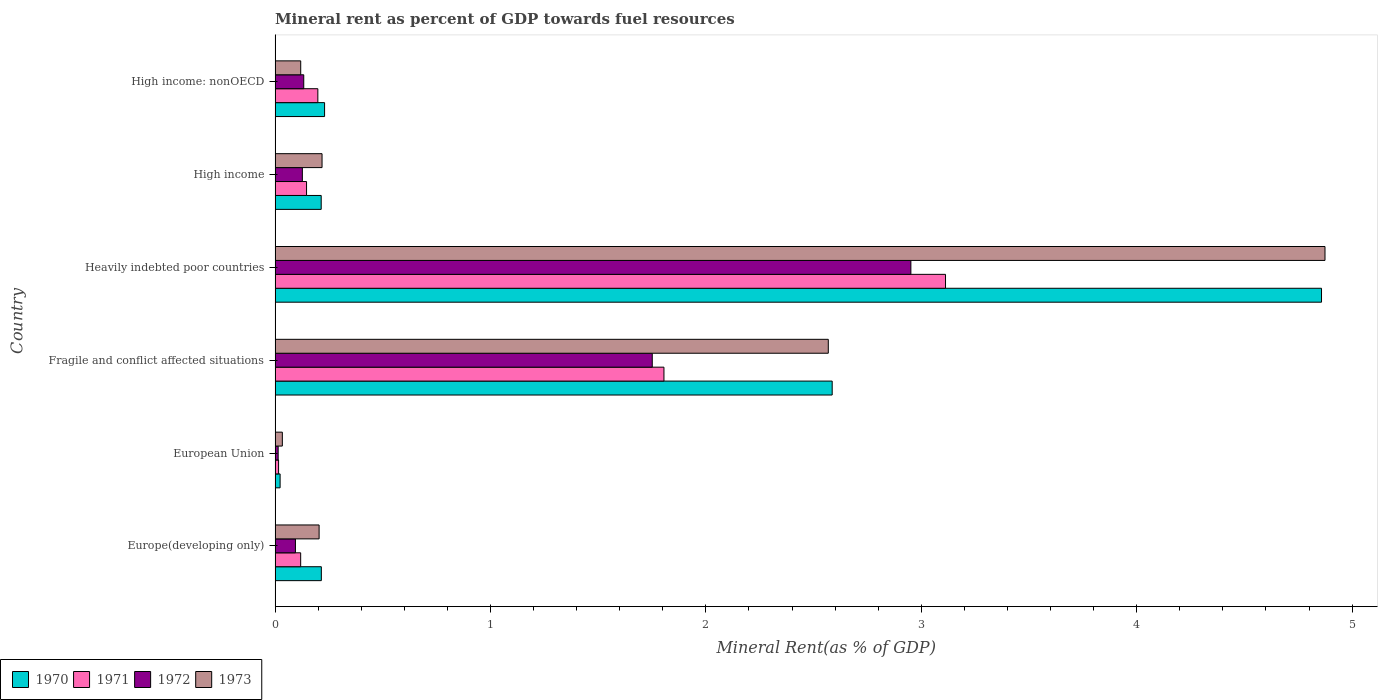How many groups of bars are there?
Make the answer very short. 6. Are the number of bars per tick equal to the number of legend labels?
Provide a succinct answer. Yes. Are the number of bars on each tick of the Y-axis equal?
Your answer should be compact. Yes. How many bars are there on the 1st tick from the bottom?
Offer a terse response. 4. What is the label of the 2nd group of bars from the top?
Your response must be concise. High income. In how many cases, is the number of bars for a given country not equal to the number of legend labels?
Your response must be concise. 0. What is the mineral rent in 1970 in Fragile and conflict affected situations?
Your response must be concise. 2.59. Across all countries, what is the maximum mineral rent in 1973?
Offer a terse response. 4.87. Across all countries, what is the minimum mineral rent in 1970?
Your answer should be compact. 0.02. In which country was the mineral rent in 1973 maximum?
Offer a very short reply. Heavily indebted poor countries. What is the total mineral rent in 1973 in the graph?
Ensure brevity in your answer.  8.02. What is the difference between the mineral rent in 1970 in Heavily indebted poor countries and that in High income: nonOECD?
Your response must be concise. 4.63. What is the difference between the mineral rent in 1972 in Heavily indebted poor countries and the mineral rent in 1971 in Fragile and conflict affected situations?
Provide a short and direct response. 1.15. What is the average mineral rent in 1973 per country?
Ensure brevity in your answer.  1.34. What is the difference between the mineral rent in 1971 and mineral rent in 1972 in Fragile and conflict affected situations?
Your response must be concise. 0.05. In how many countries, is the mineral rent in 1972 greater than 0.8 %?
Provide a succinct answer. 2. What is the ratio of the mineral rent in 1971 in High income to that in High income: nonOECD?
Make the answer very short. 0.74. Is the mineral rent in 1972 in Fragile and conflict affected situations less than that in Heavily indebted poor countries?
Ensure brevity in your answer.  Yes. Is the difference between the mineral rent in 1971 in European Union and High income greater than the difference between the mineral rent in 1972 in European Union and High income?
Keep it short and to the point. No. What is the difference between the highest and the second highest mineral rent in 1972?
Give a very brief answer. 1.2. What is the difference between the highest and the lowest mineral rent in 1972?
Your answer should be compact. 2.94. What does the 1st bar from the top in High income: nonOECD represents?
Offer a very short reply. 1973. What does the 3rd bar from the bottom in High income represents?
Make the answer very short. 1972. How many bars are there?
Provide a succinct answer. 24. Are all the bars in the graph horizontal?
Keep it short and to the point. Yes. Are the values on the major ticks of X-axis written in scientific E-notation?
Ensure brevity in your answer.  No. Does the graph contain any zero values?
Your answer should be very brief. No. What is the title of the graph?
Keep it short and to the point. Mineral rent as percent of GDP towards fuel resources. Does "1978" appear as one of the legend labels in the graph?
Provide a short and direct response. No. What is the label or title of the X-axis?
Provide a succinct answer. Mineral Rent(as % of GDP). What is the label or title of the Y-axis?
Offer a terse response. Country. What is the Mineral Rent(as % of GDP) in 1970 in Europe(developing only)?
Provide a short and direct response. 0.21. What is the Mineral Rent(as % of GDP) in 1971 in Europe(developing only)?
Provide a short and direct response. 0.12. What is the Mineral Rent(as % of GDP) of 1972 in Europe(developing only)?
Give a very brief answer. 0.09. What is the Mineral Rent(as % of GDP) in 1973 in Europe(developing only)?
Keep it short and to the point. 0.2. What is the Mineral Rent(as % of GDP) of 1970 in European Union?
Give a very brief answer. 0.02. What is the Mineral Rent(as % of GDP) of 1971 in European Union?
Your response must be concise. 0.02. What is the Mineral Rent(as % of GDP) of 1972 in European Union?
Give a very brief answer. 0.01. What is the Mineral Rent(as % of GDP) of 1973 in European Union?
Provide a succinct answer. 0.03. What is the Mineral Rent(as % of GDP) of 1970 in Fragile and conflict affected situations?
Your answer should be very brief. 2.59. What is the Mineral Rent(as % of GDP) in 1971 in Fragile and conflict affected situations?
Keep it short and to the point. 1.81. What is the Mineral Rent(as % of GDP) in 1972 in Fragile and conflict affected situations?
Make the answer very short. 1.75. What is the Mineral Rent(as % of GDP) in 1973 in Fragile and conflict affected situations?
Your response must be concise. 2.57. What is the Mineral Rent(as % of GDP) in 1970 in Heavily indebted poor countries?
Offer a terse response. 4.86. What is the Mineral Rent(as % of GDP) of 1971 in Heavily indebted poor countries?
Keep it short and to the point. 3.11. What is the Mineral Rent(as % of GDP) in 1972 in Heavily indebted poor countries?
Give a very brief answer. 2.95. What is the Mineral Rent(as % of GDP) of 1973 in Heavily indebted poor countries?
Give a very brief answer. 4.87. What is the Mineral Rent(as % of GDP) in 1970 in High income?
Provide a succinct answer. 0.21. What is the Mineral Rent(as % of GDP) of 1971 in High income?
Give a very brief answer. 0.15. What is the Mineral Rent(as % of GDP) in 1972 in High income?
Offer a terse response. 0.13. What is the Mineral Rent(as % of GDP) of 1973 in High income?
Offer a terse response. 0.22. What is the Mineral Rent(as % of GDP) in 1970 in High income: nonOECD?
Provide a succinct answer. 0.23. What is the Mineral Rent(as % of GDP) of 1971 in High income: nonOECD?
Make the answer very short. 0.2. What is the Mineral Rent(as % of GDP) in 1972 in High income: nonOECD?
Keep it short and to the point. 0.13. What is the Mineral Rent(as % of GDP) in 1973 in High income: nonOECD?
Make the answer very short. 0.12. Across all countries, what is the maximum Mineral Rent(as % of GDP) of 1970?
Give a very brief answer. 4.86. Across all countries, what is the maximum Mineral Rent(as % of GDP) of 1971?
Keep it short and to the point. 3.11. Across all countries, what is the maximum Mineral Rent(as % of GDP) in 1972?
Give a very brief answer. 2.95. Across all countries, what is the maximum Mineral Rent(as % of GDP) in 1973?
Offer a very short reply. 4.87. Across all countries, what is the minimum Mineral Rent(as % of GDP) of 1970?
Ensure brevity in your answer.  0.02. Across all countries, what is the minimum Mineral Rent(as % of GDP) in 1971?
Provide a short and direct response. 0.02. Across all countries, what is the minimum Mineral Rent(as % of GDP) in 1972?
Provide a succinct answer. 0.01. Across all countries, what is the minimum Mineral Rent(as % of GDP) of 1973?
Your response must be concise. 0.03. What is the total Mineral Rent(as % of GDP) of 1970 in the graph?
Your answer should be compact. 8.13. What is the total Mineral Rent(as % of GDP) of 1971 in the graph?
Offer a very short reply. 5.4. What is the total Mineral Rent(as % of GDP) in 1972 in the graph?
Offer a terse response. 5.07. What is the total Mineral Rent(as % of GDP) of 1973 in the graph?
Offer a terse response. 8.02. What is the difference between the Mineral Rent(as % of GDP) in 1970 in Europe(developing only) and that in European Union?
Your answer should be compact. 0.19. What is the difference between the Mineral Rent(as % of GDP) of 1971 in Europe(developing only) and that in European Union?
Make the answer very short. 0.1. What is the difference between the Mineral Rent(as % of GDP) in 1972 in Europe(developing only) and that in European Union?
Offer a very short reply. 0.08. What is the difference between the Mineral Rent(as % of GDP) of 1973 in Europe(developing only) and that in European Union?
Your answer should be compact. 0.17. What is the difference between the Mineral Rent(as % of GDP) of 1970 in Europe(developing only) and that in Fragile and conflict affected situations?
Provide a short and direct response. -2.37. What is the difference between the Mineral Rent(as % of GDP) in 1971 in Europe(developing only) and that in Fragile and conflict affected situations?
Ensure brevity in your answer.  -1.69. What is the difference between the Mineral Rent(as % of GDP) in 1972 in Europe(developing only) and that in Fragile and conflict affected situations?
Your answer should be compact. -1.66. What is the difference between the Mineral Rent(as % of GDP) in 1973 in Europe(developing only) and that in Fragile and conflict affected situations?
Give a very brief answer. -2.36. What is the difference between the Mineral Rent(as % of GDP) in 1970 in Europe(developing only) and that in Heavily indebted poor countries?
Ensure brevity in your answer.  -4.64. What is the difference between the Mineral Rent(as % of GDP) of 1971 in Europe(developing only) and that in Heavily indebted poor countries?
Your response must be concise. -2.99. What is the difference between the Mineral Rent(as % of GDP) in 1972 in Europe(developing only) and that in Heavily indebted poor countries?
Provide a succinct answer. -2.86. What is the difference between the Mineral Rent(as % of GDP) in 1973 in Europe(developing only) and that in Heavily indebted poor countries?
Offer a very short reply. -4.67. What is the difference between the Mineral Rent(as % of GDP) in 1970 in Europe(developing only) and that in High income?
Your answer should be very brief. 0. What is the difference between the Mineral Rent(as % of GDP) of 1971 in Europe(developing only) and that in High income?
Keep it short and to the point. -0.03. What is the difference between the Mineral Rent(as % of GDP) of 1972 in Europe(developing only) and that in High income?
Provide a succinct answer. -0.03. What is the difference between the Mineral Rent(as % of GDP) in 1973 in Europe(developing only) and that in High income?
Make the answer very short. -0.01. What is the difference between the Mineral Rent(as % of GDP) in 1970 in Europe(developing only) and that in High income: nonOECD?
Give a very brief answer. -0.01. What is the difference between the Mineral Rent(as % of GDP) in 1971 in Europe(developing only) and that in High income: nonOECD?
Give a very brief answer. -0.08. What is the difference between the Mineral Rent(as % of GDP) in 1972 in Europe(developing only) and that in High income: nonOECD?
Give a very brief answer. -0.04. What is the difference between the Mineral Rent(as % of GDP) of 1973 in Europe(developing only) and that in High income: nonOECD?
Provide a succinct answer. 0.09. What is the difference between the Mineral Rent(as % of GDP) in 1970 in European Union and that in Fragile and conflict affected situations?
Provide a succinct answer. -2.56. What is the difference between the Mineral Rent(as % of GDP) of 1971 in European Union and that in Fragile and conflict affected situations?
Offer a very short reply. -1.79. What is the difference between the Mineral Rent(as % of GDP) of 1972 in European Union and that in Fragile and conflict affected situations?
Your response must be concise. -1.74. What is the difference between the Mineral Rent(as % of GDP) of 1973 in European Union and that in Fragile and conflict affected situations?
Your answer should be very brief. -2.53. What is the difference between the Mineral Rent(as % of GDP) in 1970 in European Union and that in Heavily indebted poor countries?
Keep it short and to the point. -4.83. What is the difference between the Mineral Rent(as % of GDP) in 1971 in European Union and that in Heavily indebted poor countries?
Your answer should be compact. -3.1. What is the difference between the Mineral Rent(as % of GDP) of 1972 in European Union and that in Heavily indebted poor countries?
Give a very brief answer. -2.94. What is the difference between the Mineral Rent(as % of GDP) of 1973 in European Union and that in Heavily indebted poor countries?
Your answer should be very brief. -4.84. What is the difference between the Mineral Rent(as % of GDP) of 1970 in European Union and that in High income?
Provide a succinct answer. -0.19. What is the difference between the Mineral Rent(as % of GDP) in 1971 in European Union and that in High income?
Offer a very short reply. -0.13. What is the difference between the Mineral Rent(as % of GDP) in 1972 in European Union and that in High income?
Your response must be concise. -0.11. What is the difference between the Mineral Rent(as % of GDP) of 1973 in European Union and that in High income?
Your answer should be compact. -0.18. What is the difference between the Mineral Rent(as % of GDP) of 1970 in European Union and that in High income: nonOECD?
Your answer should be compact. -0.21. What is the difference between the Mineral Rent(as % of GDP) in 1971 in European Union and that in High income: nonOECD?
Your response must be concise. -0.18. What is the difference between the Mineral Rent(as % of GDP) of 1972 in European Union and that in High income: nonOECD?
Your answer should be compact. -0.12. What is the difference between the Mineral Rent(as % of GDP) of 1973 in European Union and that in High income: nonOECD?
Your answer should be very brief. -0.09. What is the difference between the Mineral Rent(as % of GDP) in 1970 in Fragile and conflict affected situations and that in Heavily indebted poor countries?
Give a very brief answer. -2.27. What is the difference between the Mineral Rent(as % of GDP) of 1971 in Fragile and conflict affected situations and that in Heavily indebted poor countries?
Your response must be concise. -1.31. What is the difference between the Mineral Rent(as % of GDP) in 1972 in Fragile and conflict affected situations and that in Heavily indebted poor countries?
Give a very brief answer. -1.2. What is the difference between the Mineral Rent(as % of GDP) in 1973 in Fragile and conflict affected situations and that in Heavily indebted poor countries?
Offer a very short reply. -2.31. What is the difference between the Mineral Rent(as % of GDP) in 1970 in Fragile and conflict affected situations and that in High income?
Provide a short and direct response. 2.37. What is the difference between the Mineral Rent(as % of GDP) of 1971 in Fragile and conflict affected situations and that in High income?
Your answer should be compact. 1.66. What is the difference between the Mineral Rent(as % of GDP) of 1972 in Fragile and conflict affected situations and that in High income?
Make the answer very short. 1.62. What is the difference between the Mineral Rent(as % of GDP) of 1973 in Fragile and conflict affected situations and that in High income?
Your answer should be very brief. 2.35. What is the difference between the Mineral Rent(as % of GDP) of 1970 in Fragile and conflict affected situations and that in High income: nonOECD?
Keep it short and to the point. 2.36. What is the difference between the Mineral Rent(as % of GDP) of 1971 in Fragile and conflict affected situations and that in High income: nonOECD?
Your answer should be compact. 1.61. What is the difference between the Mineral Rent(as % of GDP) in 1972 in Fragile and conflict affected situations and that in High income: nonOECD?
Ensure brevity in your answer.  1.62. What is the difference between the Mineral Rent(as % of GDP) in 1973 in Fragile and conflict affected situations and that in High income: nonOECD?
Keep it short and to the point. 2.45. What is the difference between the Mineral Rent(as % of GDP) of 1970 in Heavily indebted poor countries and that in High income?
Provide a succinct answer. 4.64. What is the difference between the Mineral Rent(as % of GDP) of 1971 in Heavily indebted poor countries and that in High income?
Offer a very short reply. 2.97. What is the difference between the Mineral Rent(as % of GDP) in 1972 in Heavily indebted poor countries and that in High income?
Your answer should be very brief. 2.82. What is the difference between the Mineral Rent(as % of GDP) of 1973 in Heavily indebted poor countries and that in High income?
Make the answer very short. 4.66. What is the difference between the Mineral Rent(as % of GDP) in 1970 in Heavily indebted poor countries and that in High income: nonOECD?
Give a very brief answer. 4.63. What is the difference between the Mineral Rent(as % of GDP) of 1971 in Heavily indebted poor countries and that in High income: nonOECD?
Offer a terse response. 2.91. What is the difference between the Mineral Rent(as % of GDP) of 1972 in Heavily indebted poor countries and that in High income: nonOECD?
Your response must be concise. 2.82. What is the difference between the Mineral Rent(as % of GDP) in 1973 in Heavily indebted poor countries and that in High income: nonOECD?
Provide a short and direct response. 4.75. What is the difference between the Mineral Rent(as % of GDP) in 1970 in High income and that in High income: nonOECD?
Provide a succinct answer. -0.02. What is the difference between the Mineral Rent(as % of GDP) in 1971 in High income and that in High income: nonOECD?
Offer a very short reply. -0.05. What is the difference between the Mineral Rent(as % of GDP) in 1972 in High income and that in High income: nonOECD?
Give a very brief answer. -0.01. What is the difference between the Mineral Rent(as % of GDP) in 1973 in High income and that in High income: nonOECD?
Your answer should be very brief. 0.1. What is the difference between the Mineral Rent(as % of GDP) of 1970 in Europe(developing only) and the Mineral Rent(as % of GDP) of 1971 in European Union?
Provide a succinct answer. 0.2. What is the difference between the Mineral Rent(as % of GDP) in 1970 in Europe(developing only) and the Mineral Rent(as % of GDP) in 1972 in European Union?
Make the answer very short. 0.2. What is the difference between the Mineral Rent(as % of GDP) of 1970 in Europe(developing only) and the Mineral Rent(as % of GDP) of 1973 in European Union?
Keep it short and to the point. 0.18. What is the difference between the Mineral Rent(as % of GDP) of 1971 in Europe(developing only) and the Mineral Rent(as % of GDP) of 1972 in European Union?
Make the answer very short. 0.1. What is the difference between the Mineral Rent(as % of GDP) of 1971 in Europe(developing only) and the Mineral Rent(as % of GDP) of 1973 in European Union?
Ensure brevity in your answer.  0.09. What is the difference between the Mineral Rent(as % of GDP) of 1972 in Europe(developing only) and the Mineral Rent(as % of GDP) of 1973 in European Union?
Give a very brief answer. 0.06. What is the difference between the Mineral Rent(as % of GDP) of 1970 in Europe(developing only) and the Mineral Rent(as % of GDP) of 1971 in Fragile and conflict affected situations?
Give a very brief answer. -1.59. What is the difference between the Mineral Rent(as % of GDP) in 1970 in Europe(developing only) and the Mineral Rent(as % of GDP) in 1972 in Fragile and conflict affected situations?
Provide a short and direct response. -1.54. What is the difference between the Mineral Rent(as % of GDP) in 1970 in Europe(developing only) and the Mineral Rent(as % of GDP) in 1973 in Fragile and conflict affected situations?
Ensure brevity in your answer.  -2.35. What is the difference between the Mineral Rent(as % of GDP) of 1971 in Europe(developing only) and the Mineral Rent(as % of GDP) of 1972 in Fragile and conflict affected situations?
Ensure brevity in your answer.  -1.63. What is the difference between the Mineral Rent(as % of GDP) of 1971 in Europe(developing only) and the Mineral Rent(as % of GDP) of 1973 in Fragile and conflict affected situations?
Your response must be concise. -2.45. What is the difference between the Mineral Rent(as % of GDP) of 1972 in Europe(developing only) and the Mineral Rent(as % of GDP) of 1973 in Fragile and conflict affected situations?
Your answer should be compact. -2.47. What is the difference between the Mineral Rent(as % of GDP) in 1970 in Europe(developing only) and the Mineral Rent(as % of GDP) in 1971 in Heavily indebted poor countries?
Provide a succinct answer. -2.9. What is the difference between the Mineral Rent(as % of GDP) in 1970 in Europe(developing only) and the Mineral Rent(as % of GDP) in 1972 in Heavily indebted poor countries?
Your answer should be compact. -2.74. What is the difference between the Mineral Rent(as % of GDP) in 1970 in Europe(developing only) and the Mineral Rent(as % of GDP) in 1973 in Heavily indebted poor countries?
Your response must be concise. -4.66. What is the difference between the Mineral Rent(as % of GDP) of 1971 in Europe(developing only) and the Mineral Rent(as % of GDP) of 1972 in Heavily indebted poor countries?
Keep it short and to the point. -2.83. What is the difference between the Mineral Rent(as % of GDP) in 1971 in Europe(developing only) and the Mineral Rent(as % of GDP) in 1973 in Heavily indebted poor countries?
Offer a very short reply. -4.76. What is the difference between the Mineral Rent(as % of GDP) in 1972 in Europe(developing only) and the Mineral Rent(as % of GDP) in 1973 in Heavily indebted poor countries?
Your answer should be very brief. -4.78. What is the difference between the Mineral Rent(as % of GDP) in 1970 in Europe(developing only) and the Mineral Rent(as % of GDP) in 1971 in High income?
Ensure brevity in your answer.  0.07. What is the difference between the Mineral Rent(as % of GDP) of 1970 in Europe(developing only) and the Mineral Rent(as % of GDP) of 1972 in High income?
Make the answer very short. 0.09. What is the difference between the Mineral Rent(as % of GDP) of 1970 in Europe(developing only) and the Mineral Rent(as % of GDP) of 1973 in High income?
Your answer should be very brief. -0. What is the difference between the Mineral Rent(as % of GDP) in 1971 in Europe(developing only) and the Mineral Rent(as % of GDP) in 1972 in High income?
Your response must be concise. -0.01. What is the difference between the Mineral Rent(as % of GDP) of 1971 in Europe(developing only) and the Mineral Rent(as % of GDP) of 1973 in High income?
Ensure brevity in your answer.  -0.1. What is the difference between the Mineral Rent(as % of GDP) of 1972 in Europe(developing only) and the Mineral Rent(as % of GDP) of 1973 in High income?
Ensure brevity in your answer.  -0.12. What is the difference between the Mineral Rent(as % of GDP) in 1970 in Europe(developing only) and the Mineral Rent(as % of GDP) in 1971 in High income: nonOECD?
Provide a succinct answer. 0.02. What is the difference between the Mineral Rent(as % of GDP) of 1970 in Europe(developing only) and the Mineral Rent(as % of GDP) of 1972 in High income: nonOECD?
Ensure brevity in your answer.  0.08. What is the difference between the Mineral Rent(as % of GDP) in 1970 in Europe(developing only) and the Mineral Rent(as % of GDP) in 1973 in High income: nonOECD?
Your response must be concise. 0.1. What is the difference between the Mineral Rent(as % of GDP) of 1971 in Europe(developing only) and the Mineral Rent(as % of GDP) of 1972 in High income: nonOECD?
Make the answer very short. -0.01. What is the difference between the Mineral Rent(as % of GDP) in 1971 in Europe(developing only) and the Mineral Rent(as % of GDP) in 1973 in High income: nonOECD?
Offer a terse response. -0. What is the difference between the Mineral Rent(as % of GDP) in 1972 in Europe(developing only) and the Mineral Rent(as % of GDP) in 1973 in High income: nonOECD?
Your answer should be compact. -0.02. What is the difference between the Mineral Rent(as % of GDP) of 1970 in European Union and the Mineral Rent(as % of GDP) of 1971 in Fragile and conflict affected situations?
Your answer should be very brief. -1.78. What is the difference between the Mineral Rent(as % of GDP) of 1970 in European Union and the Mineral Rent(as % of GDP) of 1972 in Fragile and conflict affected situations?
Offer a terse response. -1.73. What is the difference between the Mineral Rent(as % of GDP) in 1970 in European Union and the Mineral Rent(as % of GDP) in 1973 in Fragile and conflict affected situations?
Keep it short and to the point. -2.54. What is the difference between the Mineral Rent(as % of GDP) in 1971 in European Union and the Mineral Rent(as % of GDP) in 1972 in Fragile and conflict affected situations?
Offer a terse response. -1.73. What is the difference between the Mineral Rent(as % of GDP) of 1971 in European Union and the Mineral Rent(as % of GDP) of 1973 in Fragile and conflict affected situations?
Make the answer very short. -2.55. What is the difference between the Mineral Rent(as % of GDP) of 1972 in European Union and the Mineral Rent(as % of GDP) of 1973 in Fragile and conflict affected situations?
Give a very brief answer. -2.55. What is the difference between the Mineral Rent(as % of GDP) in 1970 in European Union and the Mineral Rent(as % of GDP) in 1971 in Heavily indebted poor countries?
Provide a short and direct response. -3.09. What is the difference between the Mineral Rent(as % of GDP) of 1970 in European Union and the Mineral Rent(as % of GDP) of 1972 in Heavily indebted poor countries?
Make the answer very short. -2.93. What is the difference between the Mineral Rent(as % of GDP) in 1970 in European Union and the Mineral Rent(as % of GDP) in 1973 in Heavily indebted poor countries?
Your answer should be compact. -4.85. What is the difference between the Mineral Rent(as % of GDP) in 1971 in European Union and the Mineral Rent(as % of GDP) in 1972 in Heavily indebted poor countries?
Your answer should be compact. -2.94. What is the difference between the Mineral Rent(as % of GDP) in 1971 in European Union and the Mineral Rent(as % of GDP) in 1973 in Heavily indebted poor countries?
Provide a short and direct response. -4.86. What is the difference between the Mineral Rent(as % of GDP) of 1972 in European Union and the Mineral Rent(as % of GDP) of 1973 in Heavily indebted poor countries?
Ensure brevity in your answer.  -4.86. What is the difference between the Mineral Rent(as % of GDP) in 1970 in European Union and the Mineral Rent(as % of GDP) in 1971 in High income?
Your response must be concise. -0.12. What is the difference between the Mineral Rent(as % of GDP) of 1970 in European Union and the Mineral Rent(as % of GDP) of 1972 in High income?
Ensure brevity in your answer.  -0.1. What is the difference between the Mineral Rent(as % of GDP) in 1970 in European Union and the Mineral Rent(as % of GDP) in 1973 in High income?
Provide a succinct answer. -0.19. What is the difference between the Mineral Rent(as % of GDP) of 1971 in European Union and the Mineral Rent(as % of GDP) of 1972 in High income?
Offer a terse response. -0.11. What is the difference between the Mineral Rent(as % of GDP) of 1971 in European Union and the Mineral Rent(as % of GDP) of 1973 in High income?
Provide a short and direct response. -0.2. What is the difference between the Mineral Rent(as % of GDP) of 1972 in European Union and the Mineral Rent(as % of GDP) of 1973 in High income?
Provide a succinct answer. -0.2. What is the difference between the Mineral Rent(as % of GDP) of 1970 in European Union and the Mineral Rent(as % of GDP) of 1971 in High income: nonOECD?
Offer a terse response. -0.18. What is the difference between the Mineral Rent(as % of GDP) of 1970 in European Union and the Mineral Rent(as % of GDP) of 1972 in High income: nonOECD?
Make the answer very short. -0.11. What is the difference between the Mineral Rent(as % of GDP) in 1970 in European Union and the Mineral Rent(as % of GDP) in 1973 in High income: nonOECD?
Offer a very short reply. -0.1. What is the difference between the Mineral Rent(as % of GDP) of 1971 in European Union and the Mineral Rent(as % of GDP) of 1972 in High income: nonOECD?
Offer a very short reply. -0.12. What is the difference between the Mineral Rent(as % of GDP) in 1971 in European Union and the Mineral Rent(as % of GDP) in 1973 in High income: nonOECD?
Make the answer very short. -0.1. What is the difference between the Mineral Rent(as % of GDP) in 1972 in European Union and the Mineral Rent(as % of GDP) in 1973 in High income: nonOECD?
Make the answer very short. -0.1. What is the difference between the Mineral Rent(as % of GDP) in 1970 in Fragile and conflict affected situations and the Mineral Rent(as % of GDP) in 1971 in Heavily indebted poor countries?
Provide a short and direct response. -0.53. What is the difference between the Mineral Rent(as % of GDP) in 1970 in Fragile and conflict affected situations and the Mineral Rent(as % of GDP) in 1972 in Heavily indebted poor countries?
Give a very brief answer. -0.37. What is the difference between the Mineral Rent(as % of GDP) in 1970 in Fragile and conflict affected situations and the Mineral Rent(as % of GDP) in 1973 in Heavily indebted poor countries?
Keep it short and to the point. -2.29. What is the difference between the Mineral Rent(as % of GDP) of 1971 in Fragile and conflict affected situations and the Mineral Rent(as % of GDP) of 1972 in Heavily indebted poor countries?
Your answer should be very brief. -1.15. What is the difference between the Mineral Rent(as % of GDP) of 1971 in Fragile and conflict affected situations and the Mineral Rent(as % of GDP) of 1973 in Heavily indebted poor countries?
Ensure brevity in your answer.  -3.07. What is the difference between the Mineral Rent(as % of GDP) in 1972 in Fragile and conflict affected situations and the Mineral Rent(as % of GDP) in 1973 in Heavily indebted poor countries?
Your answer should be very brief. -3.12. What is the difference between the Mineral Rent(as % of GDP) of 1970 in Fragile and conflict affected situations and the Mineral Rent(as % of GDP) of 1971 in High income?
Offer a very short reply. 2.44. What is the difference between the Mineral Rent(as % of GDP) in 1970 in Fragile and conflict affected situations and the Mineral Rent(as % of GDP) in 1972 in High income?
Your answer should be very brief. 2.46. What is the difference between the Mineral Rent(as % of GDP) of 1970 in Fragile and conflict affected situations and the Mineral Rent(as % of GDP) of 1973 in High income?
Your answer should be very brief. 2.37. What is the difference between the Mineral Rent(as % of GDP) in 1971 in Fragile and conflict affected situations and the Mineral Rent(as % of GDP) in 1972 in High income?
Provide a succinct answer. 1.68. What is the difference between the Mineral Rent(as % of GDP) of 1971 in Fragile and conflict affected situations and the Mineral Rent(as % of GDP) of 1973 in High income?
Ensure brevity in your answer.  1.59. What is the difference between the Mineral Rent(as % of GDP) of 1972 in Fragile and conflict affected situations and the Mineral Rent(as % of GDP) of 1973 in High income?
Provide a short and direct response. 1.53. What is the difference between the Mineral Rent(as % of GDP) of 1970 in Fragile and conflict affected situations and the Mineral Rent(as % of GDP) of 1971 in High income: nonOECD?
Offer a terse response. 2.39. What is the difference between the Mineral Rent(as % of GDP) in 1970 in Fragile and conflict affected situations and the Mineral Rent(as % of GDP) in 1972 in High income: nonOECD?
Give a very brief answer. 2.45. What is the difference between the Mineral Rent(as % of GDP) of 1970 in Fragile and conflict affected situations and the Mineral Rent(as % of GDP) of 1973 in High income: nonOECD?
Provide a short and direct response. 2.47. What is the difference between the Mineral Rent(as % of GDP) in 1971 in Fragile and conflict affected situations and the Mineral Rent(as % of GDP) in 1972 in High income: nonOECD?
Ensure brevity in your answer.  1.67. What is the difference between the Mineral Rent(as % of GDP) in 1971 in Fragile and conflict affected situations and the Mineral Rent(as % of GDP) in 1973 in High income: nonOECD?
Make the answer very short. 1.69. What is the difference between the Mineral Rent(as % of GDP) in 1972 in Fragile and conflict affected situations and the Mineral Rent(as % of GDP) in 1973 in High income: nonOECD?
Provide a short and direct response. 1.63. What is the difference between the Mineral Rent(as % of GDP) in 1970 in Heavily indebted poor countries and the Mineral Rent(as % of GDP) in 1971 in High income?
Make the answer very short. 4.71. What is the difference between the Mineral Rent(as % of GDP) of 1970 in Heavily indebted poor countries and the Mineral Rent(as % of GDP) of 1972 in High income?
Give a very brief answer. 4.73. What is the difference between the Mineral Rent(as % of GDP) in 1970 in Heavily indebted poor countries and the Mineral Rent(as % of GDP) in 1973 in High income?
Your response must be concise. 4.64. What is the difference between the Mineral Rent(as % of GDP) of 1971 in Heavily indebted poor countries and the Mineral Rent(as % of GDP) of 1972 in High income?
Keep it short and to the point. 2.99. What is the difference between the Mineral Rent(as % of GDP) in 1971 in Heavily indebted poor countries and the Mineral Rent(as % of GDP) in 1973 in High income?
Your answer should be compact. 2.89. What is the difference between the Mineral Rent(as % of GDP) of 1972 in Heavily indebted poor countries and the Mineral Rent(as % of GDP) of 1973 in High income?
Make the answer very short. 2.73. What is the difference between the Mineral Rent(as % of GDP) of 1970 in Heavily indebted poor countries and the Mineral Rent(as % of GDP) of 1971 in High income: nonOECD?
Provide a succinct answer. 4.66. What is the difference between the Mineral Rent(as % of GDP) of 1970 in Heavily indebted poor countries and the Mineral Rent(as % of GDP) of 1972 in High income: nonOECD?
Offer a very short reply. 4.72. What is the difference between the Mineral Rent(as % of GDP) in 1970 in Heavily indebted poor countries and the Mineral Rent(as % of GDP) in 1973 in High income: nonOECD?
Your answer should be compact. 4.74. What is the difference between the Mineral Rent(as % of GDP) of 1971 in Heavily indebted poor countries and the Mineral Rent(as % of GDP) of 1972 in High income: nonOECD?
Your response must be concise. 2.98. What is the difference between the Mineral Rent(as % of GDP) of 1971 in Heavily indebted poor countries and the Mineral Rent(as % of GDP) of 1973 in High income: nonOECD?
Offer a very short reply. 2.99. What is the difference between the Mineral Rent(as % of GDP) in 1972 in Heavily indebted poor countries and the Mineral Rent(as % of GDP) in 1973 in High income: nonOECD?
Provide a succinct answer. 2.83. What is the difference between the Mineral Rent(as % of GDP) in 1970 in High income and the Mineral Rent(as % of GDP) in 1971 in High income: nonOECD?
Your answer should be very brief. 0.02. What is the difference between the Mineral Rent(as % of GDP) of 1970 in High income and the Mineral Rent(as % of GDP) of 1972 in High income: nonOECD?
Give a very brief answer. 0.08. What is the difference between the Mineral Rent(as % of GDP) in 1970 in High income and the Mineral Rent(as % of GDP) in 1973 in High income: nonOECD?
Offer a terse response. 0.1. What is the difference between the Mineral Rent(as % of GDP) in 1971 in High income and the Mineral Rent(as % of GDP) in 1972 in High income: nonOECD?
Your answer should be very brief. 0.01. What is the difference between the Mineral Rent(as % of GDP) in 1971 in High income and the Mineral Rent(as % of GDP) in 1973 in High income: nonOECD?
Give a very brief answer. 0.03. What is the difference between the Mineral Rent(as % of GDP) of 1972 in High income and the Mineral Rent(as % of GDP) of 1973 in High income: nonOECD?
Keep it short and to the point. 0.01. What is the average Mineral Rent(as % of GDP) of 1970 per country?
Provide a succinct answer. 1.35. What is the average Mineral Rent(as % of GDP) in 1971 per country?
Provide a succinct answer. 0.9. What is the average Mineral Rent(as % of GDP) in 1972 per country?
Give a very brief answer. 0.85. What is the average Mineral Rent(as % of GDP) of 1973 per country?
Your answer should be very brief. 1.34. What is the difference between the Mineral Rent(as % of GDP) of 1970 and Mineral Rent(as % of GDP) of 1971 in Europe(developing only)?
Your answer should be compact. 0.1. What is the difference between the Mineral Rent(as % of GDP) in 1970 and Mineral Rent(as % of GDP) in 1972 in Europe(developing only)?
Ensure brevity in your answer.  0.12. What is the difference between the Mineral Rent(as % of GDP) of 1970 and Mineral Rent(as % of GDP) of 1973 in Europe(developing only)?
Give a very brief answer. 0.01. What is the difference between the Mineral Rent(as % of GDP) in 1971 and Mineral Rent(as % of GDP) in 1972 in Europe(developing only)?
Your answer should be compact. 0.02. What is the difference between the Mineral Rent(as % of GDP) in 1971 and Mineral Rent(as % of GDP) in 1973 in Europe(developing only)?
Keep it short and to the point. -0.09. What is the difference between the Mineral Rent(as % of GDP) of 1972 and Mineral Rent(as % of GDP) of 1973 in Europe(developing only)?
Keep it short and to the point. -0.11. What is the difference between the Mineral Rent(as % of GDP) of 1970 and Mineral Rent(as % of GDP) of 1971 in European Union?
Give a very brief answer. 0.01. What is the difference between the Mineral Rent(as % of GDP) of 1970 and Mineral Rent(as % of GDP) of 1972 in European Union?
Offer a terse response. 0.01. What is the difference between the Mineral Rent(as % of GDP) of 1970 and Mineral Rent(as % of GDP) of 1973 in European Union?
Offer a very short reply. -0.01. What is the difference between the Mineral Rent(as % of GDP) in 1971 and Mineral Rent(as % of GDP) in 1972 in European Union?
Provide a succinct answer. 0. What is the difference between the Mineral Rent(as % of GDP) of 1971 and Mineral Rent(as % of GDP) of 1973 in European Union?
Your response must be concise. -0.02. What is the difference between the Mineral Rent(as % of GDP) of 1972 and Mineral Rent(as % of GDP) of 1973 in European Union?
Offer a very short reply. -0.02. What is the difference between the Mineral Rent(as % of GDP) in 1970 and Mineral Rent(as % of GDP) in 1971 in Fragile and conflict affected situations?
Ensure brevity in your answer.  0.78. What is the difference between the Mineral Rent(as % of GDP) of 1970 and Mineral Rent(as % of GDP) of 1972 in Fragile and conflict affected situations?
Offer a very short reply. 0.84. What is the difference between the Mineral Rent(as % of GDP) of 1970 and Mineral Rent(as % of GDP) of 1973 in Fragile and conflict affected situations?
Ensure brevity in your answer.  0.02. What is the difference between the Mineral Rent(as % of GDP) in 1971 and Mineral Rent(as % of GDP) in 1972 in Fragile and conflict affected situations?
Provide a succinct answer. 0.05. What is the difference between the Mineral Rent(as % of GDP) of 1971 and Mineral Rent(as % of GDP) of 1973 in Fragile and conflict affected situations?
Provide a short and direct response. -0.76. What is the difference between the Mineral Rent(as % of GDP) of 1972 and Mineral Rent(as % of GDP) of 1973 in Fragile and conflict affected situations?
Ensure brevity in your answer.  -0.82. What is the difference between the Mineral Rent(as % of GDP) in 1970 and Mineral Rent(as % of GDP) in 1971 in Heavily indebted poor countries?
Your response must be concise. 1.75. What is the difference between the Mineral Rent(as % of GDP) of 1970 and Mineral Rent(as % of GDP) of 1972 in Heavily indebted poor countries?
Give a very brief answer. 1.91. What is the difference between the Mineral Rent(as % of GDP) in 1970 and Mineral Rent(as % of GDP) in 1973 in Heavily indebted poor countries?
Your answer should be very brief. -0.02. What is the difference between the Mineral Rent(as % of GDP) of 1971 and Mineral Rent(as % of GDP) of 1972 in Heavily indebted poor countries?
Ensure brevity in your answer.  0.16. What is the difference between the Mineral Rent(as % of GDP) in 1971 and Mineral Rent(as % of GDP) in 1973 in Heavily indebted poor countries?
Give a very brief answer. -1.76. What is the difference between the Mineral Rent(as % of GDP) in 1972 and Mineral Rent(as % of GDP) in 1973 in Heavily indebted poor countries?
Your answer should be very brief. -1.92. What is the difference between the Mineral Rent(as % of GDP) in 1970 and Mineral Rent(as % of GDP) in 1971 in High income?
Ensure brevity in your answer.  0.07. What is the difference between the Mineral Rent(as % of GDP) in 1970 and Mineral Rent(as % of GDP) in 1972 in High income?
Your response must be concise. 0.09. What is the difference between the Mineral Rent(as % of GDP) of 1970 and Mineral Rent(as % of GDP) of 1973 in High income?
Your answer should be compact. -0. What is the difference between the Mineral Rent(as % of GDP) of 1971 and Mineral Rent(as % of GDP) of 1972 in High income?
Your response must be concise. 0.02. What is the difference between the Mineral Rent(as % of GDP) in 1971 and Mineral Rent(as % of GDP) in 1973 in High income?
Offer a very short reply. -0.07. What is the difference between the Mineral Rent(as % of GDP) in 1972 and Mineral Rent(as % of GDP) in 1973 in High income?
Make the answer very short. -0.09. What is the difference between the Mineral Rent(as % of GDP) of 1970 and Mineral Rent(as % of GDP) of 1971 in High income: nonOECD?
Ensure brevity in your answer.  0.03. What is the difference between the Mineral Rent(as % of GDP) in 1970 and Mineral Rent(as % of GDP) in 1972 in High income: nonOECD?
Give a very brief answer. 0.1. What is the difference between the Mineral Rent(as % of GDP) in 1970 and Mineral Rent(as % of GDP) in 1973 in High income: nonOECD?
Your response must be concise. 0.11. What is the difference between the Mineral Rent(as % of GDP) in 1971 and Mineral Rent(as % of GDP) in 1972 in High income: nonOECD?
Offer a terse response. 0.07. What is the difference between the Mineral Rent(as % of GDP) in 1971 and Mineral Rent(as % of GDP) in 1973 in High income: nonOECD?
Provide a succinct answer. 0.08. What is the difference between the Mineral Rent(as % of GDP) of 1972 and Mineral Rent(as % of GDP) of 1973 in High income: nonOECD?
Keep it short and to the point. 0.01. What is the ratio of the Mineral Rent(as % of GDP) in 1970 in Europe(developing only) to that in European Union?
Make the answer very short. 9.2. What is the ratio of the Mineral Rent(as % of GDP) in 1971 in Europe(developing only) to that in European Union?
Ensure brevity in your answer.  7.31. What is the ratio of the Mineral Rent(as % of GDP) of 1972 in Europe(developing only) to that in European Union?
Your answer should be very brief. 6.59. What is the ratio of the Mineral Rent(as % of GDP) of 1973 in Europe(developing only) to that in European Union?
Your answer should be very brief. 6.06. What is the ratio of the Mineral Rent(as % of GDP) in 1970 in Europe(developing only) to that in Fragile and conflict affected situations?
Keep it short and to the point. 0.08. What is the ratio of the Mineral Rent(as % of GDP) of 1971 in Europe(developing only) to that in Fragile and conflict affected situations?
Offer a terse response. 0.07. What is the ratio of the Mineral Rent(as % of GDP) in 1972 in Europe(developing only) to that in Fragile and conflict affected situations?
Your answer should be very brief. 0.05. What is the ratio of the Mineral Rent(as % of GDP) of 1973 in Europe(developing only) to that in Fragile and conflict affected situations?
Your answer should be very brief. 0.08. What is the ratio of the Mineral Rent(as % of GDP) in 1970 in Europe(developing only) to that in Heavily indebted poor countries?
Provide a short and direct response. 0.04. What is the ratio of the Mineral Rent(as % of GDP) in 1971 in Europe(developing only) to that in Heavily indebted poor countries?
Give a very brief answer. 0.04. What is the ratio of the Mineral Rent(as % of GDP) of 1972 in Europe(developing only) to that in Heavily indebted poor countries?
Your answer should be compact. 0.03. What is the ratio of the Mineral Rent(as % of GDP) of 1973 in Europe(developing only) to that in Heavily indebted poor countries?
Offer a very short reply. 0.04. What is the ratio of the Mineral Rent(as % of GDP) of 1970 in Europe(developing only) to that in High income?
Your answer should be very brief. 1. What is the ratio of the Mineral Rent(as % of GDP) in 1971 in Europe(developing only) to that in High income?
Provide a succinct answer. 0.81. What is the ratio of the Mineral Rent(as % of GDP) of 1972 in Europe(developing only) to that in High income?
Ensure brevity in your answer.  0.75. What is the ratio of the Mineral Rent(as % of GDP) in 1973 in Europe(developing only) to that in High income?
Offer a terse response. 0.94. What is the ratio of the Mineral Rent(as % of GDP) of 1970 in Europe(developing only) to that in High income: nonOECD?
Offer a terse response. 0.93. What is the ratio of the Mineral Rent(as % of GDP) of 1971 in Europe(developing only) to that in High income: nonOECD?
Offer a very short reply. 0.6. What is the ratio of the Mineral Rent(as % of GDP) of 1972 in Europe(developing only) to that in High income: nonOECD?
Your response must be concise. 0.71. What is the ratio of the Mineral Rent(as % of GDP) in 1973 in Europe(developing only) to that in High income: nonOECD?
Ensure brevity in your answer.  1.72. What is the ratio of the Mineral Rent(as % of GDP) in 1970 in European Union to that in Fragile and conflict affected situations?
Your response must be concise. 0.01. What is the ratio of the Mineral Rent(as % of GDP) in 1971 in European Union to that in Fragile and conflict affected situations?
Give a very brief answer. 0.01. What is the ratio of the Mineral Rent(as % of GDP) in 1972 in European Union to that in Fragile and conflict affected situations?
Give a very brief answer. 0.01. What is the ratio of the Mineral Rent(as % of GDP) of 1973 in European Union to that in Fragile and conflict affected situations?
Provide a succinct answer. 0.01. What is the ratio of the Mineral Rent(as % of GDP) of 1970 in European Union to that in Heavily indebted poor countries?
Provide a succinct answer. 0. What is the ratio of the Mineral Rent(as % of GDP) of 1971 in European Union to that in Heavily indebted poor countries?
Ensure brevity in your answer.  0.01. What is the ratio of the Mineral Rent(as % of GDP) in 1972 in European Union to that in Heavily indebted poor countries?
Provide a short and direct response. 0. What is the ratio of the Mineral Rent(as % of GDP) of 1973 in European Union to that in Heavily indebted poor countries?
Your answer should be compact. 0.01. What is the ratio of the Mineral Rent(as % of GDP) in 1970 in European Union to that in High income?
Keep it short and to the point. 0.11. What is the ratio of the Mineral Rent(as % of GDP) of 1971 in European Union to that in High income?
Your answer should be compact. 0.11. What is the ratio of the Mineral Rent(as % of GDP) of 1972 in European Union to that in High income?
Your answer should be compact. 0.11. What is the ratio of the Mineral Rent(as % of GDP) of 1973 in European Union to that in High income?
Ensure brevity in your answer.  0.15. What is the ratio of the Mineral Rent(as % of GDP) in 1970 in European Union to that in High income: nonOECD?
Ensure brevity in your answer.  0.1. What is the ratio of the Mineral Rent(as % of GDP) of 1971 in European Union to that in High income: nonOECD?
Your answer should be compact. 0.08. What is the ratio of the Mineral Rent(as % of GDP) in 1972 in European Union to that in High income: nonOECD?
Make the answer very short. 0.11. What is the ratio of the Mineral Rent(as % of GDP) in 1973 in European Union to that in High income: nonOECD?
Your answer should be very brief. 0.28. What is the ratio of the Mineral Rent(as % of GDP) in 1970 in Fragile and conflict affected situations to that in Heavily indebted poor countries?
Keep it short and to the point. 0.53. What is the ratio of the Mineral Rent(as % of GDP) of 1971 in Fragile and conflict affected situations to that in Heavily indebted poor countries?
Keep it short and to the point. 0.58. What is the ratio of the Mineral Rent(as % of GDP) of 1972 in Fragile and conflict affected situations to that in Heavily indebted poor countries?
Your response must be concise. 0.59. What is the ratio of the Mineral Rent(as % of GDP) in 1973 in Fragile and conflict affected situations to that in Heavily indebted poor countries?
Ensure brevity in your answer.  0.53. What is the ratio of the Mineral Rent(as % of GDP) of 1970 in Fragile and conflict affected situations to that in High income?
Your response must be concise. 12.08. What is the ratio of the Mineral Rent(as % of GDP) in 1971 in Fragile and conflict affected situations to that in High income?
Your answer should be very brief. 12.36. What is the ratio of the Mineral Rent(as % of GDP) in 1972 in Fragile and conflict affected situations to that in High income?
Keep it short and to the point. 13.82. What is the ratio of the Mineral Rent(as % of GDP) in 1973 in Fragile and conflict affected situations to that in High income?
Offer a terse response. 11.78. What is the ratio of the Mineral Rent(as % of GDP) in 1970 in Fragile and conflict affected situations to that in High income: nonOECD?
Offer a terse response. 11.26. What is the ratio of the Mineral Rent(as % of GDP) in 1971 in Fragile and conflict affected situations to that in High income: nonOECD?
Give a very brief answer. 9.09. What is the ratio of the Mineral Rent(as % of GDP) in 1972 in Fragile and conflict affected situations to that in High income: nonOECD?
Offer a terse response. 13.15. What is the ratio of the Mineral Rent(as % of GDP) of 1973 in Fragile and conflict affected situations to that in High income: nonOECD?
Provide a short and direct response. 21.58. What is the ratio of the Mineral Rent(as % of GDP) of 1970 in Heavily indebted poor countries to that in High income?
Ensure brevity in your answer.  22.69. What is the ratio of the Mineral Rent(as % of GDP) of 1971 in Heavily indebted poor countries to that in High income?
Keep it short and to the point. 21.31. What is the ratio of the Mineral Rent(as % of GDP) in 1972 in Heavily indebted poor countries to that in High income?
Ensure brevity in your answer.  23.3. What is the ratio of the Mineral Rent(as % of GDP) of 1973 in Heavily indebted poor countries to that in High income?
Provide a short and direct response. 22.35. What is the ratio of the Mineral Rent(as % of GDP) of 1970 in Heavily indebted poor countries to that in High income: nonOECD?
Keep it short and to the point. 21.14. What is the ratio of the Mineral Rent(as % of GDP) in 1971 in Heavily indebted poor countries to that in High income: nonOECD?
Ensure brevity in your answer.  15.68. What is the ratio of the Mineral Rent(as % of GDP) in 1972 in Heavily indebted poor countries to that in High income: nonOECD?
Give a very brief answer. 22.17. What is the ratio of the Mineral Rent(as % of GDP) of 1973 in Heavily indebted poor countries to that in High income: nonOECD?
Offer a very short reply. 40.95. What is the ratio of the Mineral Rent(as % of GDP) in 1970 in High income to that in High income: nonOECD?
Keep it short and to the point. 0.93. What is the ratio of the Mineral Rent(as % of GDP) of 1971 in High income to that in High income: nonOECD?
Provide a short and direct response. 0.74. What is the ratio of the Mineral Rent(as % of GDP) of 1972 in High income to that in High income: nonOECD?
Your response must be concise. 0.95. What is the ratio of the Mineral Rent(as % of GDP) in 1973 in High income to that in High income: nonOECD?
Offer a terse response. 1.83. What is the difference between the highest and the second highest Mineral Rent(as % of GDP) of 1970?
Keep it short and to the point. 2.27. What is the difference between the highest and the second highest Mineral Rent(as % of GDP) of 1971?
Offer a very short reply. 1.31. What is the difference between the highest and the second highest Mineral Rent(as % of GDP) in 1972?
Your answer should be very brief. 1.2. What is the difference between the highest and the second highest Mineral Rent(as % of GDP) in 1973?
Provide a succinct answer. 2.31. What is the difference between the highest and the lowest Mineral Rent(as % of GDP) in 1970?
Offer a very short reply. 4.83. What is the difference between the highest and the lowest Mineral Rent(as % of GDP) of 1971?
Keep it short and to the point. 3.1. What is the difference between the highest and the lowest Mineral Rent(as % of GDP) of 1972?
Your answer should be very brief. 2.94. What is the difference between the highest and the lowest Mineral Rent(as % of GDP) of 1973?
Offer a very short reply. 4.84. 